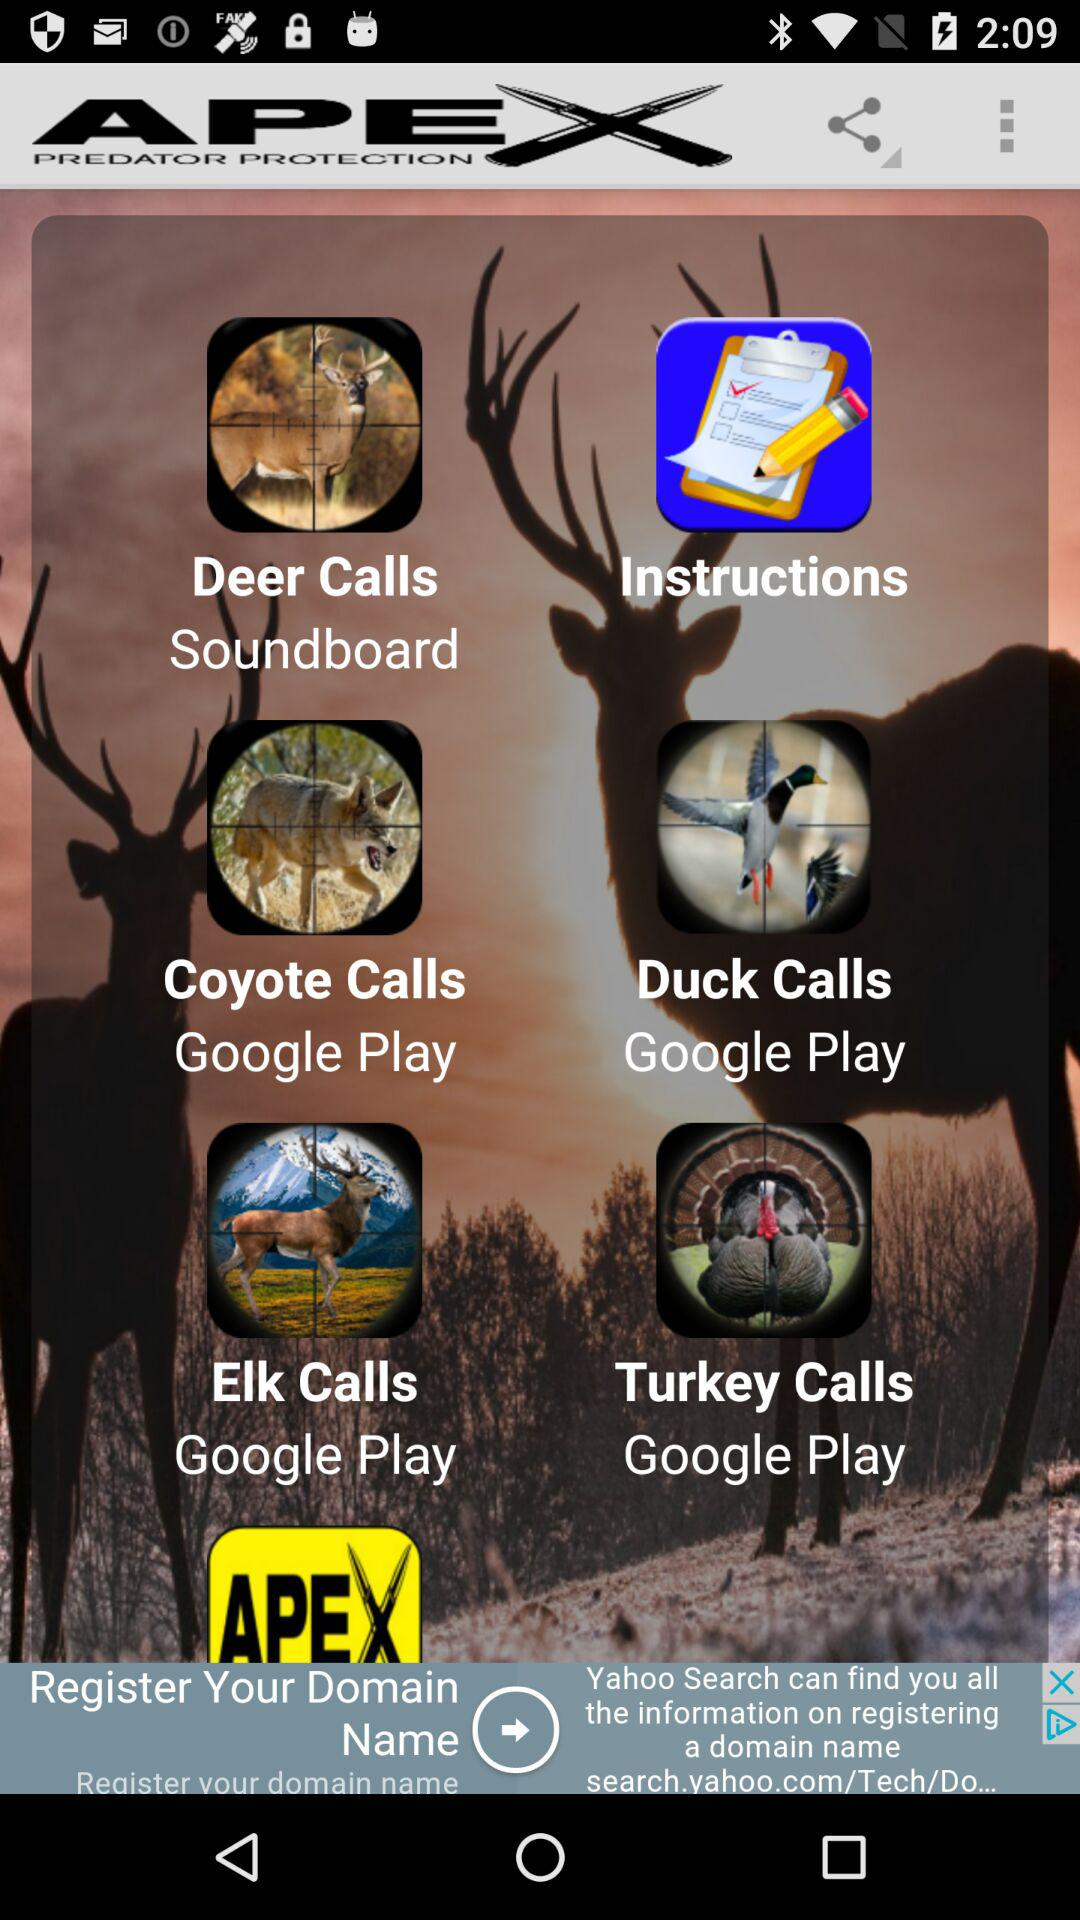What is the name of the application? The application name is "APEX PREDATOR PROTECTION". 